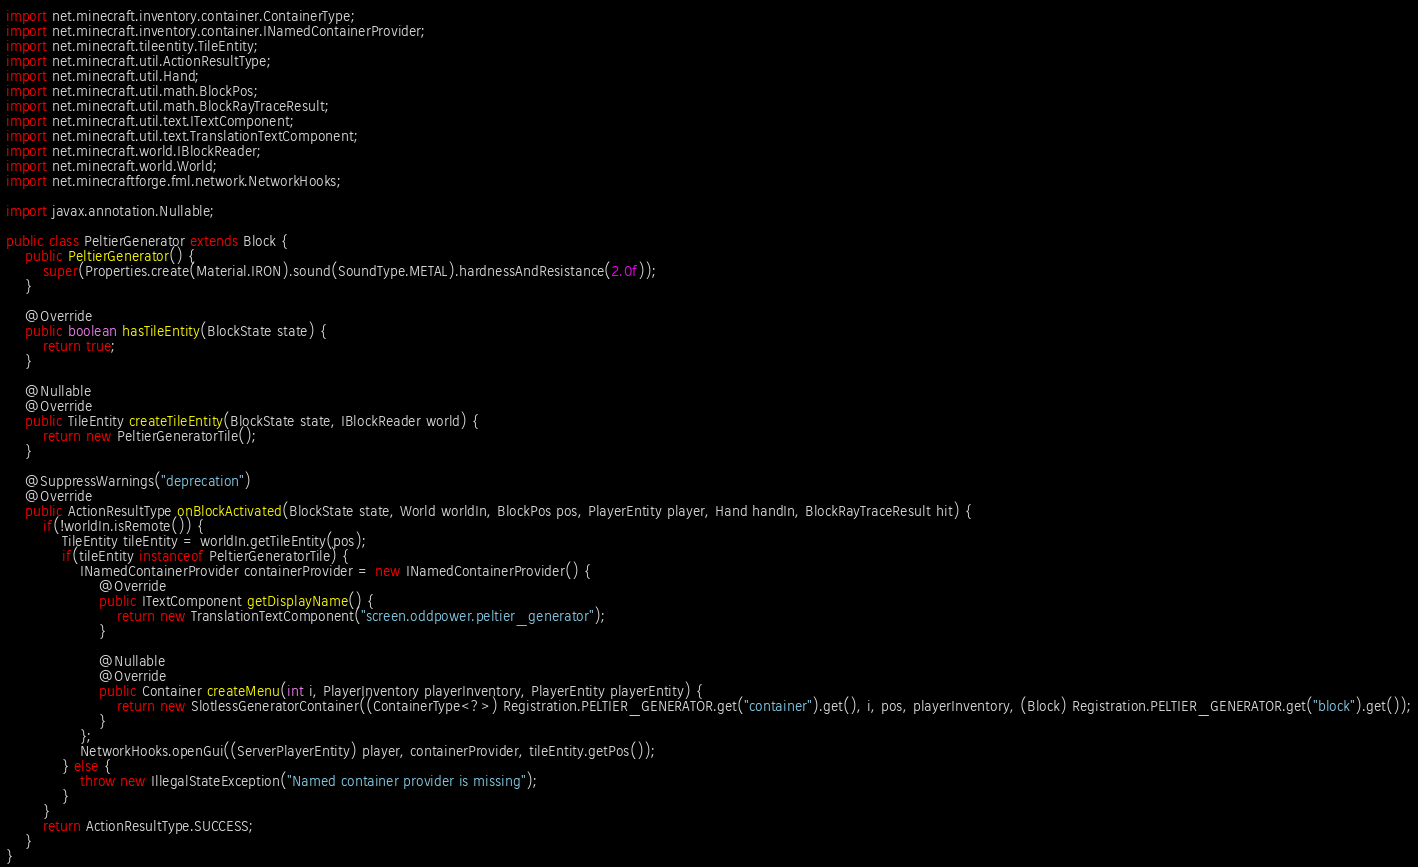<code> <loc_0><loc_0><loc_500><loc_500><_Java_>import net.minecraft.inventory.container.ContainerType;
import net.minecraft.inventory.container.INamedContainerProvider;
import net.minecraft.tileentity.TileEntity;
import net.minecraft.util.ActionResultType;
import net.minecraft.util.Hand;
import net.minecraft.util.math.BlockPos;
import net.minecraft.util.math.BlockRayTraceResult;
import net.minecraft.util.text.ITextComponent;
import net.minecraft.util.text.TranslationTextComponent;
import net.minecraft.world.IBlockReader;
import net.minecraft.world.World;
import net.minecraftforge.fml.network.NetworkHooks;

import javax.annotation.Nullable;

public class PeltierGenerator extends Block {
    public PeltierGenerator() {
        super(Properties.create(Material.IRON).sound(SoundType.METAL).hardnessAndResistance(2.0f));
    }

    @Override
    public boolean hasTileEntity(BlockState state) {
        return true;
    }

    @Nullable
    @Override
    public TileEntity createTileEntity(BlockState state, IBlockReader world) {
        return new PeltierGeneratorTile();
    }

    @SuppressWarnings("deprecation")
    @Override
    public ActionResultType onBlockActivated(BlockState state, World worldIn, BlockPos pos, PlayerEntity player, Hand handIn, BlockRayTraceResult hit) {
        if(!worldIn.isRemote()) {
            TileEntity tileEntity = worldIn.getTileEntity(pos);
            if(tileEntity instanceof PeltierGeneratorTile) {
                INamedContainerProvider containerProvider = new INamedContainerProvider() {
                    @Override
                    public ITextComponent getDisplayName() {
                        return new TranslationTextComponent("screen.oddpower.peltier_generator");
                    }

                    @Nullable
                    @Override
                    public Container createMenu(int i, PlayerInventory playerInventory, PlayerEntity playerEntity) {
                        return new SlotlessGeneratorContainer((ContainerType<?>) Registration.PELTIER_GENERATOR.get("container").get(), i, pos, playerInventory, (Block) Registration.PELTIER_GENERATOR.get("block").get());
                    }
                };
                NetworkHooks.openGui((ServerPlayerEntity) player, containerProvider, tileEntity.getPos());
            } else {
                throw new IllegalStateException("Named container provider is missing");
            }
        }
        return ActionResultType.SUCCESS;
    }
}
</code> 